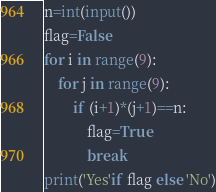<code> <loc_0><loc_0><loc_500><loc_500><_Python_>n=int(input())
flag=False
for i in range(9):
    for j in range(9):
        if (i+1)*(j+1)==n:
            flag=True
            break
print('Yes'if flag else 'No')</code> 